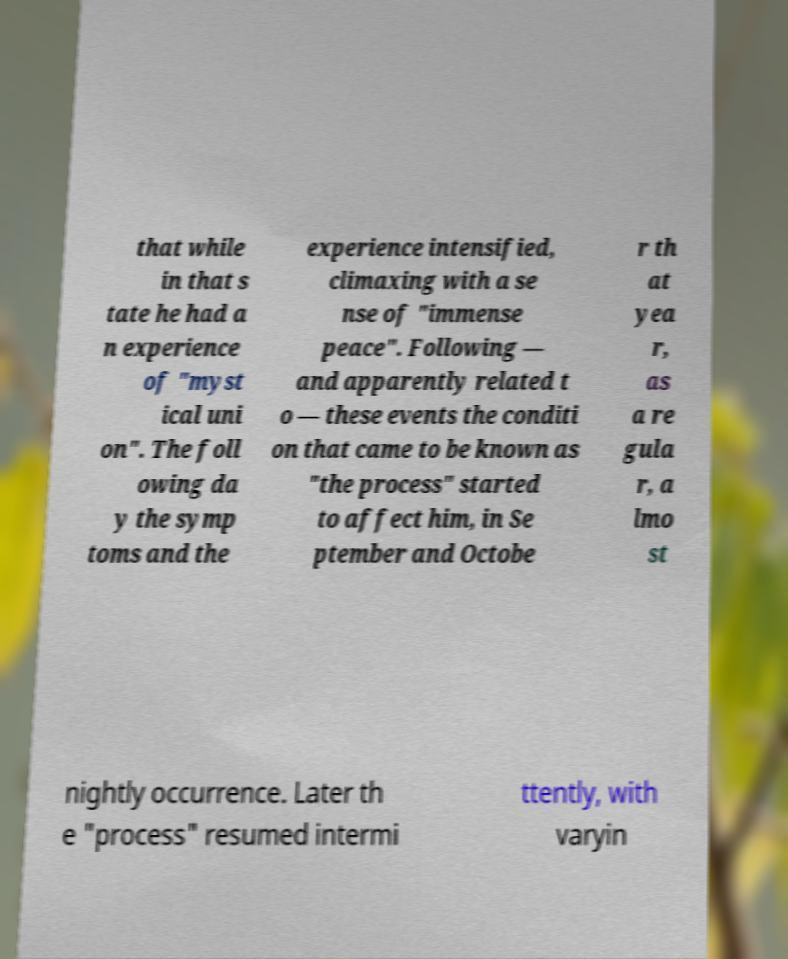For documentation purposes, I need the text within this image transcribed. Could you provide that? that while in that s tate he had a n experience of "myst ical uni on". The foll owing da y the symp toms and the experience intensified, climaxing with a se nse of "immense peace". Following — and apparently related t o — these events the conditi on that came to be known as "the process" started to affect him, in Se ptember and Octobe r th at yea r, as a re gula r, a lmo st nightly occurrence. Later th e "process" resumed intermi ttently, with varyin 